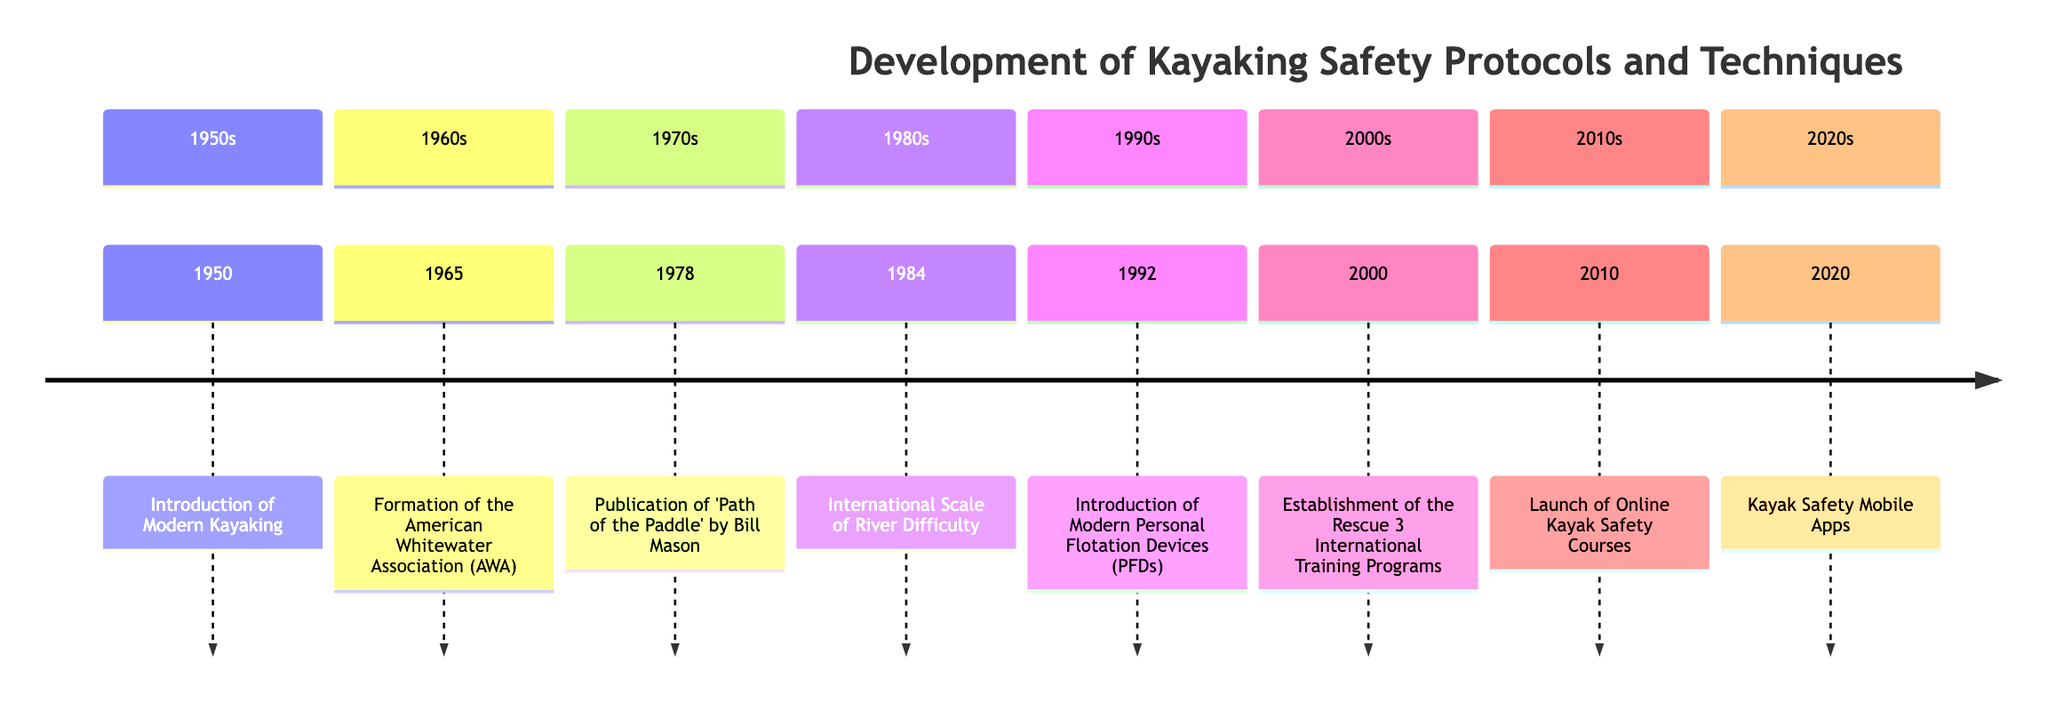What year did the American Whitewater Association (AWA) form? The diagram indicates that the event "Formation of the American Whitewater Association (AWA)" occurred in the year 1965.
Answer: 1965 What event corresponds to the year 1992? Upon reviewing the timeline, the event listed for the year 1992 is "Introduction of Modern Personal Flotation Devices (PFDs)."
Answer: Introduction of Modern Personal Flotation Devices (PFDs) How many significant events are listed in the timeline? By counting the number of distinct events mentioned in the timeline, we find a total of eight events that contribute to the development of kayaking safety protocols and techniques.
Answer: 8 What is the last event listed in the timeline? Looking at the timeline, the final event recorded is "Kayak Safety Mobile Apps," which took place in the year 2020.
Answer: Kayak Safety Mobile Apps Which event in the 1970s emphasized paddling techniques? The timeline specifies the event "Publication of 'Path of the Paddle' by Bill Mason" in 1978, highlighting its focus on paddling techniques and safety measures.
Answer: Publication of 'Path of the Paddle' by Bill Mason What safety advancement was introduced in 2000? According to the timeline, the year 2000 featured the establishment of the "Rescue 3 International Training Programs," focusing on safety and rescue training.
Answer: Establishment of the Rescue 3 International Training Programs Which decade saw the adoption of the International Scale of River Difficulty? The diagram indicates that the International Scale of River Difficulty was adopted in 1984, which falls within the 1980s.
Answer: 1980s Are there any events related to online safety training? The timeline reflects that the "Launch of Online Kayak Safety Courses" took place in 2010, marking a relevant advancement in online training for safety practices in kayaking.
Answer: Launch of Online Kayak Safety Courses 